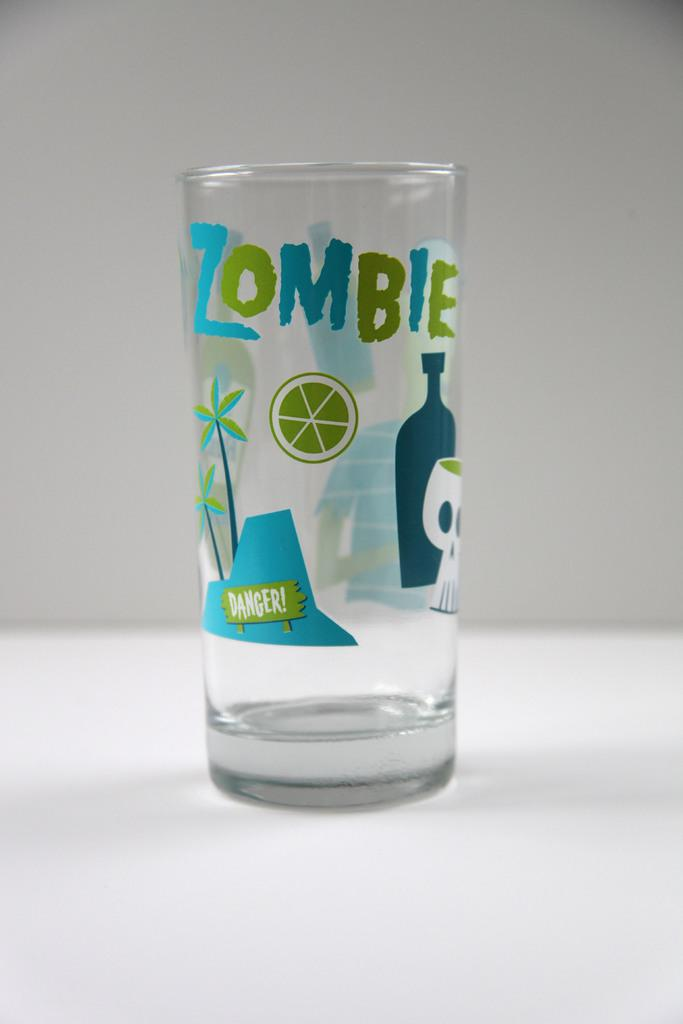<image>
Render a clear and concise summary of the photo. A glass that has some drawings of plants and skulls that says zombie. 